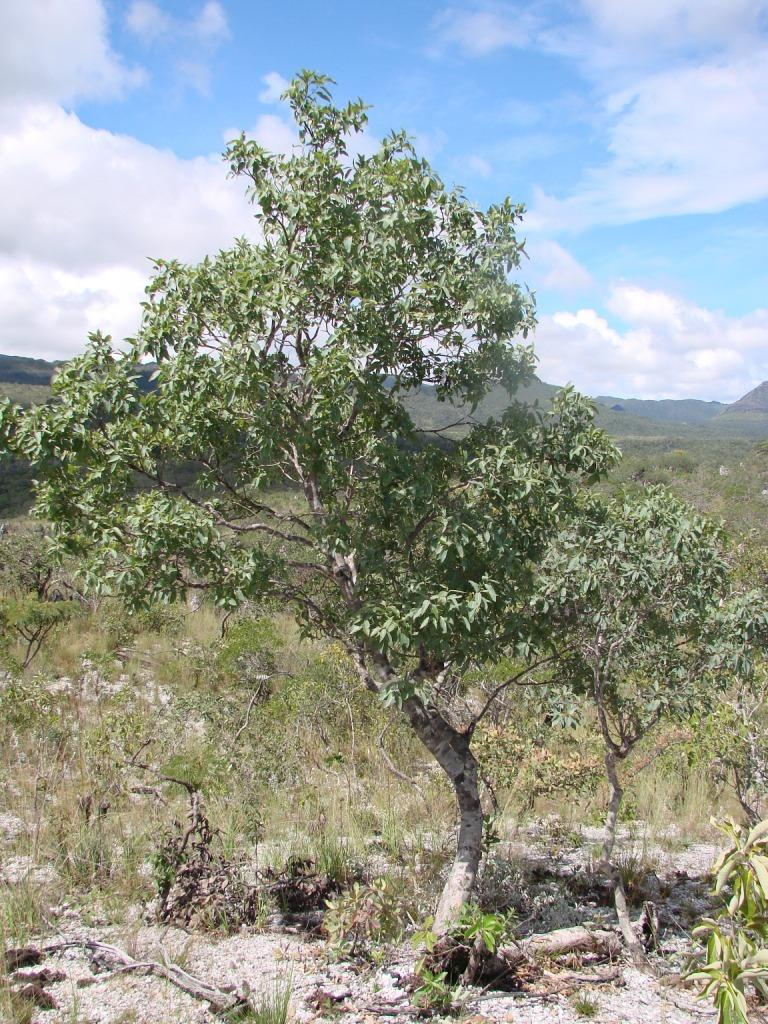What type of plant can be seen in the image? There is a tree in the image. What type of vegetation is present behind the tree? There is a lot of grass behind the tree. What geographical feature can be seen in the background of the image? There is a mountain visible in the background of the image. How many pies are stacked on the wall in the image? There are no pies or walls present in the image. 